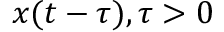Convert formula to latex. <formula><loc_0><loc_0><loc_500><loc_500>x ( t - \tau ) , \tau > 0</formula> 